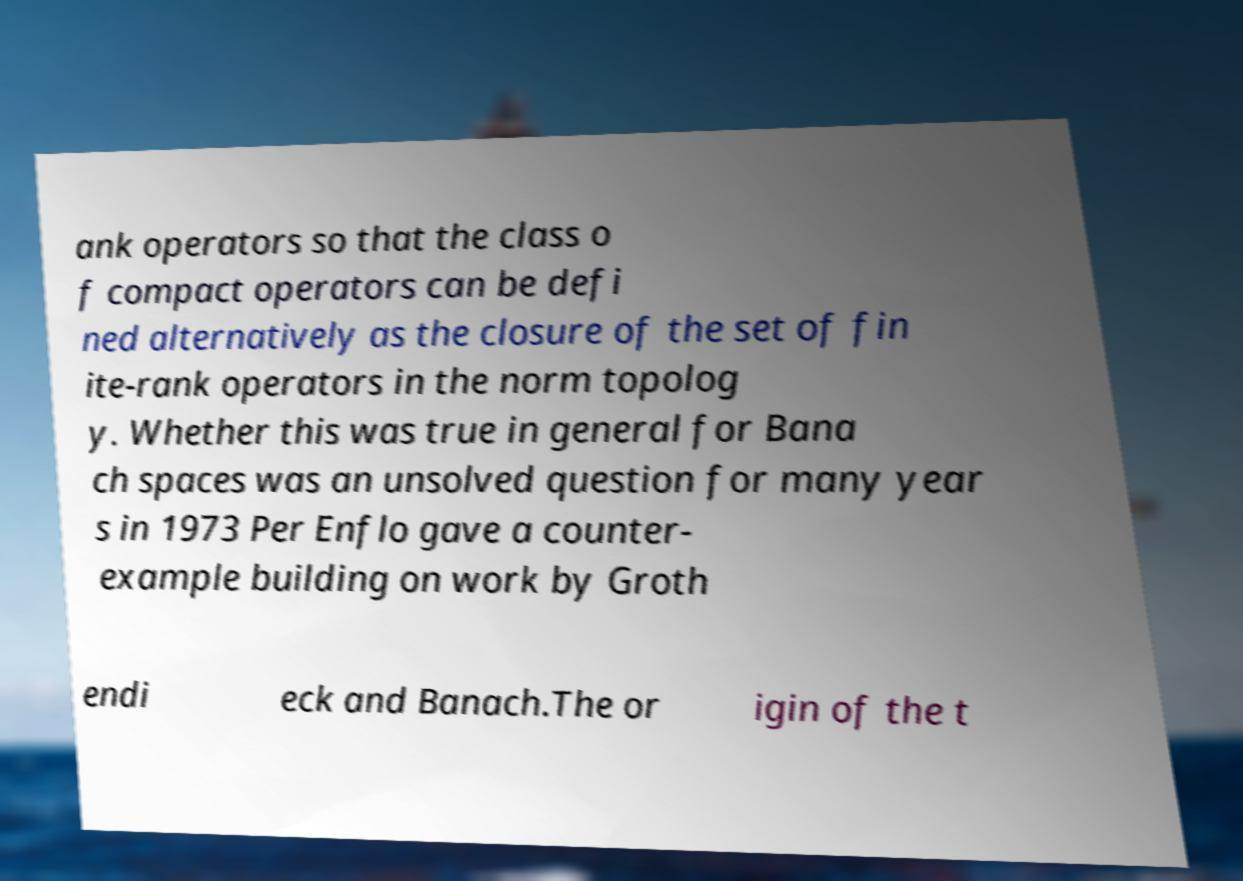I need the written content from this picture converted into text. Can you do that? ank operators so that the class o f compact operators can be defi ned alternatively as the closure of the set of fin ite-rank operators in the norm topolog y. Whether this was true in general for Bana ch spaces was an unsolved question for many year s in 1973 Per Enflo gave a counter- example building on work by Groth endi eck and Banach.The or igin of the t 